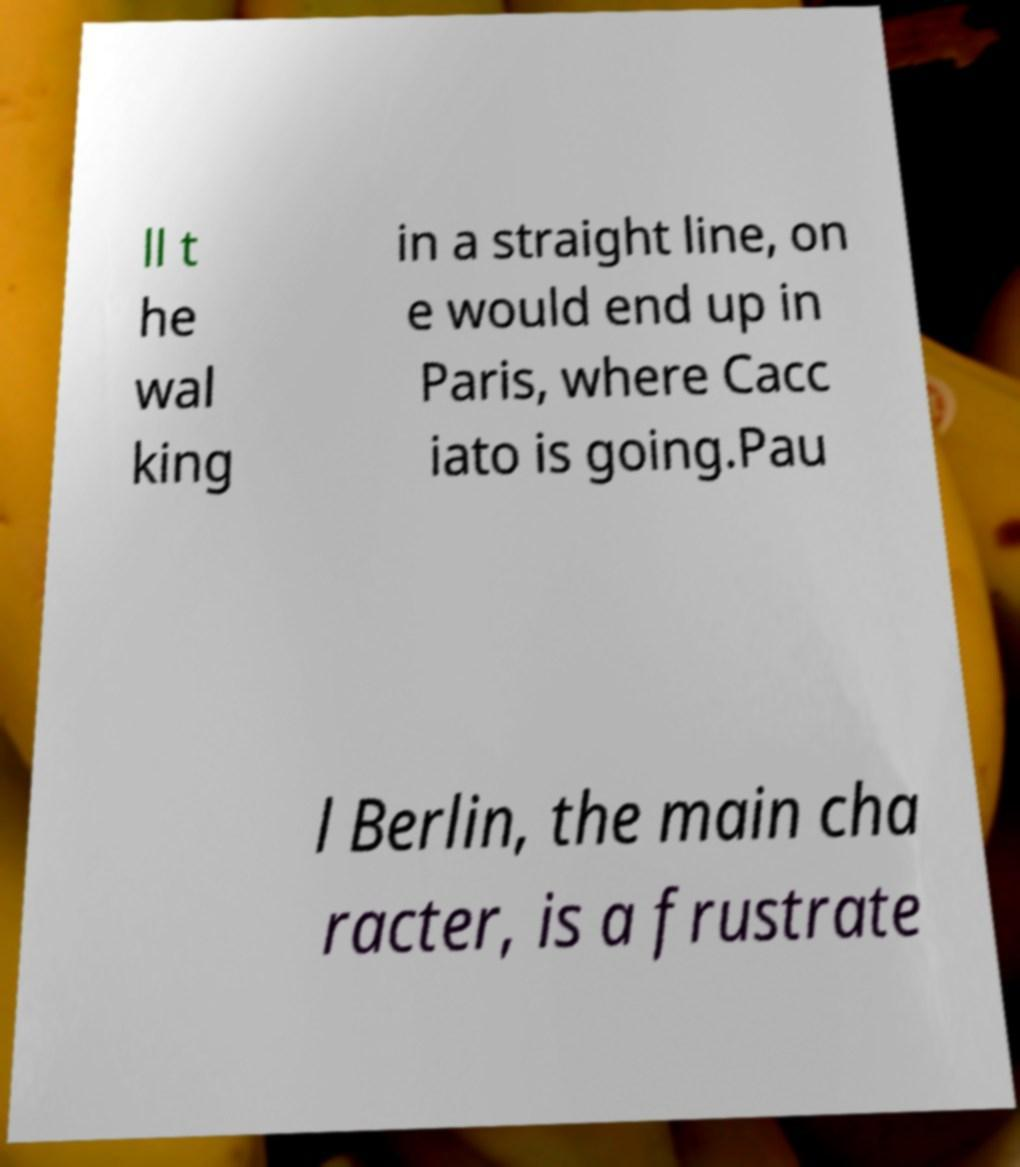For documentation purposes, I need the text within this image transcribed. Could you provide that? ll t he wal king in a straight line, on e would end up in Paris, where Cacc iato is going.Pau l Berlin, the main cha racter, is a frustrate 